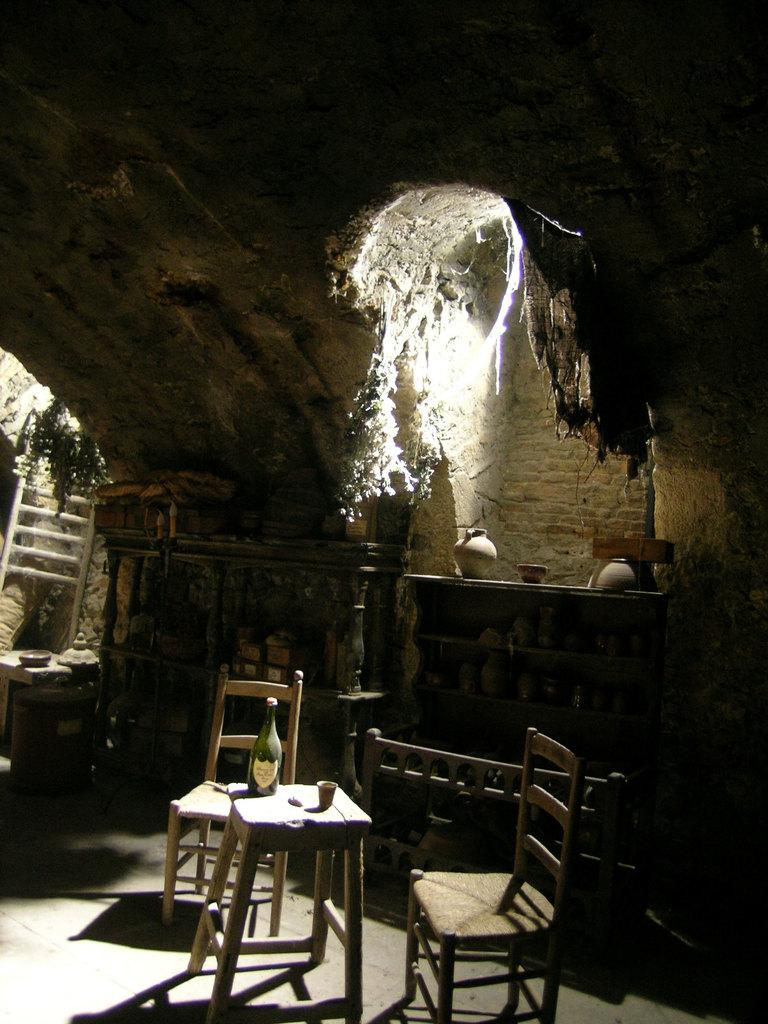What type of furniture is present in the image? There is a chair in the image. What other objects can be seen in the image? There are vessels and a bottle on the table in the image. What is the other item on the table in the image? There is a glass on the table in the image. Can you tell me how the boat is being used in the image? There is no boat present in the image. What type of development is taking place in the image? There is no development project depicted in the image. What role does the farmer play in the image? There is no farmer present in the image. 